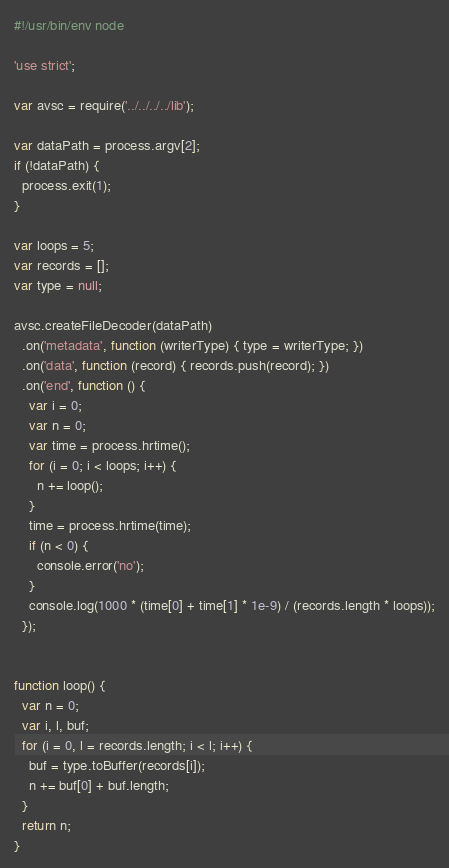<code> <loc_0><loc_0><loc_500><loc_500><_JavaScript_>#!/usr/bin/env node

'use strict';

var avsc = require('../../../../lib');

var dataPath = process.argv[2];
if (!dataPath) {
  process.exit(1);
}

var loops = 5;
var records = [];
var type = null;

avsc.createFileDecoder(dataPath)
  .on('metadata', function (writerType) { type = writerType; })
  .on('data', function (record) { records.push(record); })
  .on('end', function () {
    var i = 0;
    var n = 0;
    var time = process.hrtime();
    for (i = 0; i < loops; i++) {
      n += loop();
    }
    time = process.hrtime(time);
    if (n < 0) {
      console.error('no');
    }
    console.log(1000 * (time[0] + time[1] * 1e-9) / (records.length * loops));
  });


function loop() {
  var n = 0;
  var i, l, buf;
  for (i = 0, l = records.length; i < l; i++) {
    buf = type.toBuffer(records[i]);
    n += buf[0] + buf.length;
  }
  return n;
}
</code> 